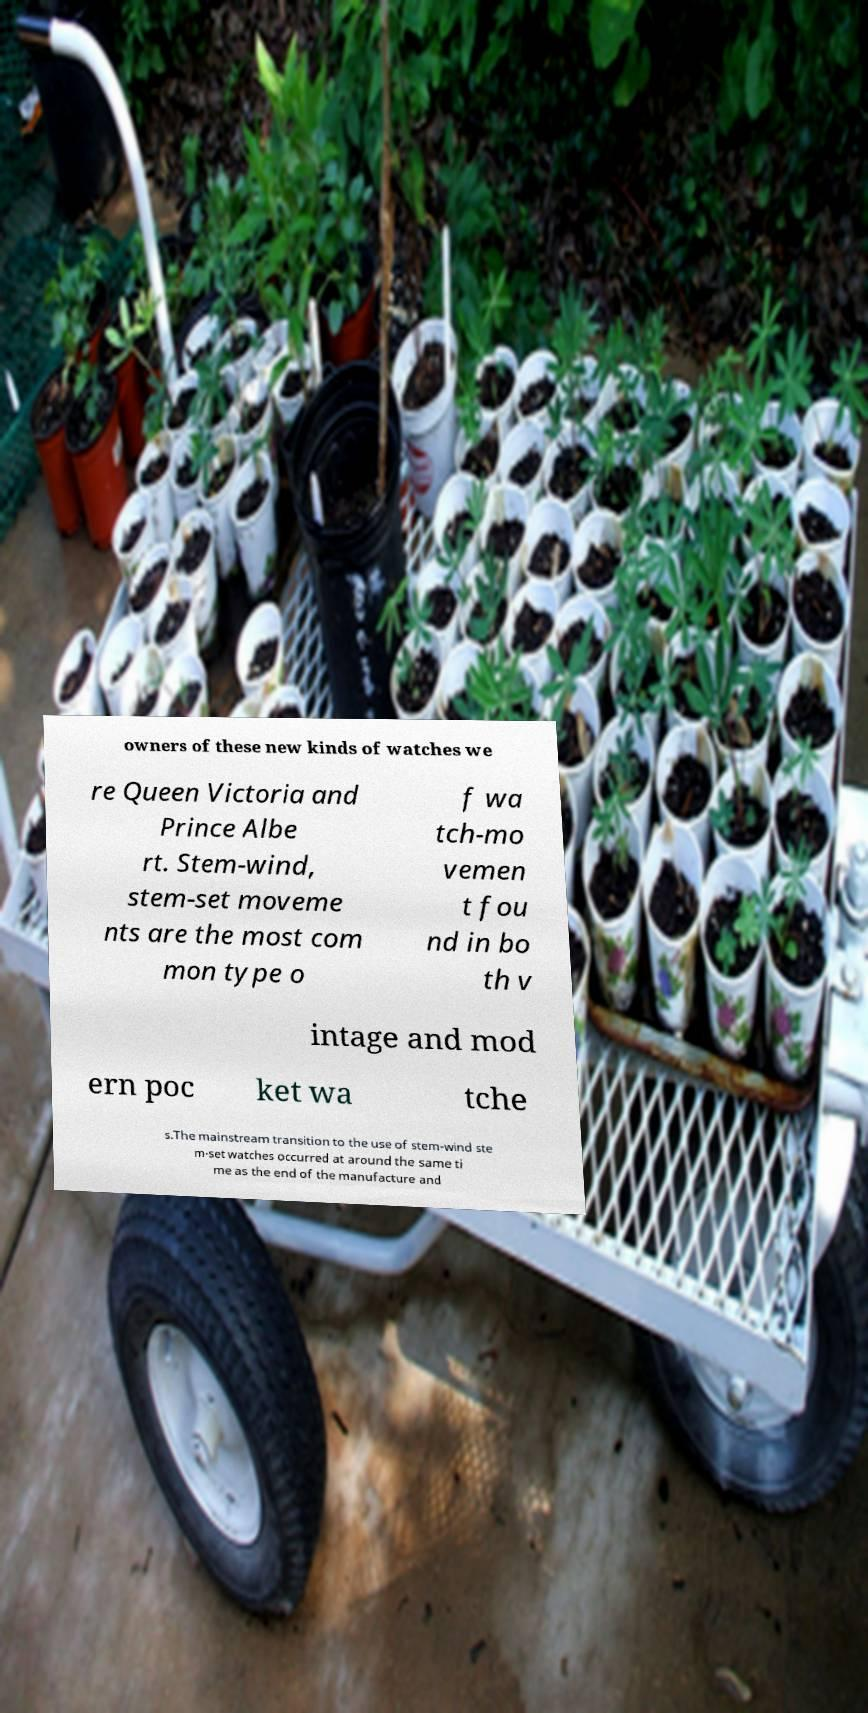Please identify and transcribe the text found in this image. owners of these new kinds of watches we re Queen Victoria and Prince Albe rt. Stem-wind, stem-set moveme nts are the most com mon type o f wa tch-mo vemen t fou nd in bo th v intage and mod ern poc ket wa tche s.The mainstream transition to the use of stem-wind ste m-set watches occurred at around the same ti me as the end of the manufacture and 